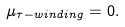<formula> <loc_0><loc_0><loc_500><loc_500>\mu _ { \tau - w i n d i n g } = 0 .</formula> 